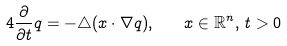<formula> <loc_0><loc_0><loc_500><loc_500>4 \frac { \partial } { \partial t } q = - \triangle ( x \cdot \nabla q ) , \quad x \in \mathbb { R } ^ { n } , \, t > 0</formula> 